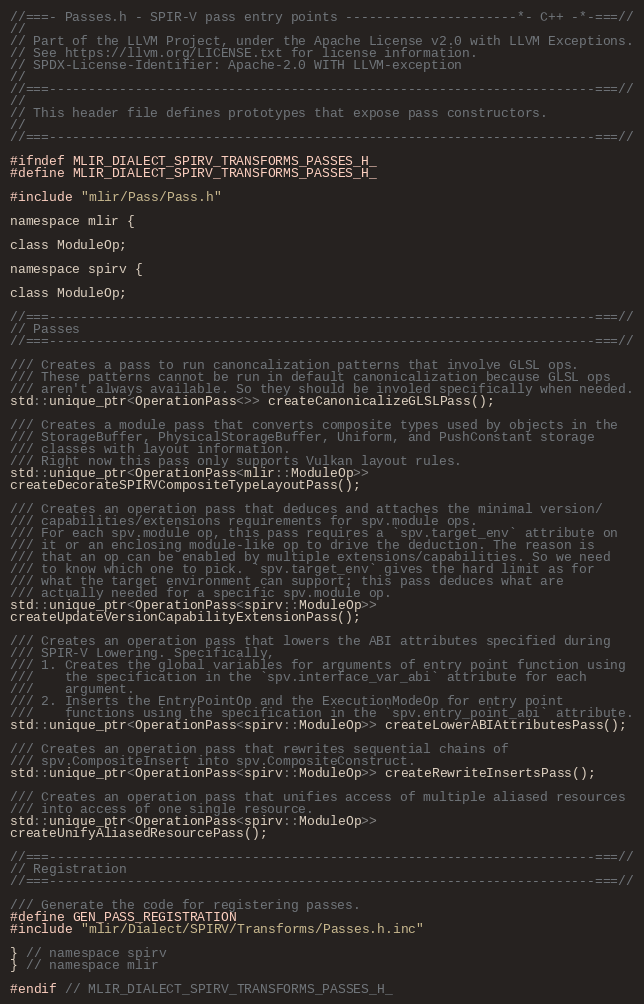Convert code to text. <code><loc_0><loc_0><loc_500><loc_500><_C_>//===- Passes.h - SPIR-V pass entry points ----------------------*- C++ -*-===//
//
// Part of the LLVM Project, under the Apache License v2.0 with LLVM Exceptions.
// See https://llvm.org/LICENSE.txt for license information.
// SPDX-License-Identifier: Apache-2.0 WITH LLVM-exception
//
//===----------------------------------------------------------------------===//
//
// This header file defines prototypes that expose pass constructors.
//
//===----------------------------------------------------------------------===//

#ifndef MLIR_DIALECT_SPIRV_TRANSFORMS_PASSES_H_
#define MLIR_DIALECT_SPIRV_TRANSFORMS_PASSES_H_

#include "mlir/Pass/Pass.h"

namespace mlir {

class ModuleOp;

namespace spirv {

class ModuleOp;

//===----------------------------------------------------------------------===//
// Passes
//===----------------------------------------------------------------------===//

/// Creates a pass to run canoncalization patterns that involve GLSL ops.
/// These patterns cannot be run in default canonicalization because GLSL ops
/// aren't always available. So they should be involed specifically when needed.
std::unique_ptr<OperationPass<>> createCanonicalizeGLSLPass();

/// Creates a module pass that converts composite types used by objects in the
/// StorageBuffer, PhysicalStorageBuffer, Uniform, and PushConstant storage
/// classes with layout information.
/// Right now this pass only supports Vulkan layout rules.
std::unique_ptr<OperationPass<mlir::ModuleOp>>
createDecorateSPIRVCompositeTypeLayoutPass();

/// Creates an operation pass that deduces and attaches the minimal version/
/// capabilities/extensions requirements for spv.module ops.
/// For each spv.module op, this pass requires a `spv.target_env` attribute on
/// it or an enclosing module-like op to drive the deduction. The reason is
/// that an op can be enabled by multiple extensions/capabilities. So we need
/// to know which one to pick. `spv.target_env` gives the hard limit as for
/// what the target environment can support; this pass deduces what are
/// actually needed for a specific spv.module op.
std::unique_ptr<OperationPass<spirv::ModuleOp>>
createUpdateVersionCapabilityExtensionPass();

/// Creates an operation pass that lowers the ABI attributes specified during
/// SPIR-V Lowering. Specifically,
/// 1. Creates the global variables for arguments of entry point function using
///    the specification in the `spv.interface_var_abi` attribute for each
///    argument.
/// 2. Inserts the EntryPointOp and the ExecutionModeOp for entry point
///    functions using the specification in the `spv.entry_point_abi` attribute.
std::unique_ptr<OperationPass<spirv::ModuleOp>> createLowerABIAttributesPass();

/// Creates an operation pass that rewrites sequential chains of
/// spv.CompositeInsert into spv.CompositeConstruct.
std::unique_ptr<OperationPass<spirv::ModuleOp>> createRewriteInsertsPass();

/// Creates an operation pass that unifies access of multiple aliased resources
/// into access of one single resource.
std::unique_ptr<OperationPass<spirv::ModuleOp>>
createUnifyAliasedResourcePass();

//===----------------------------------------------------------------------===//
// Registration
//===----------------------------------------------------------------------===//

/// Generate the code for registering passes.
#define GEN_PASS_REGISTRATION
#include "mlir/Dialect/SPIRV/Transforms/Passes.h.inc"

} // namespace spirv
} // namespace mlir

#endif // MLIR_DIALECT_SPIRV_TRANSFORMS_PASSES_H_
</code> 